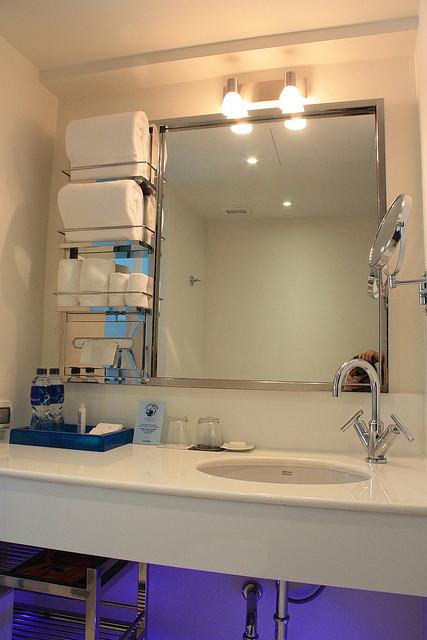What are lit in the photo?
Keep it brief. Lights. Is water coming out of the sink in this picture?
Give a very brief answer. No. Are the lights on at this location?
Be succinct. Yes. 